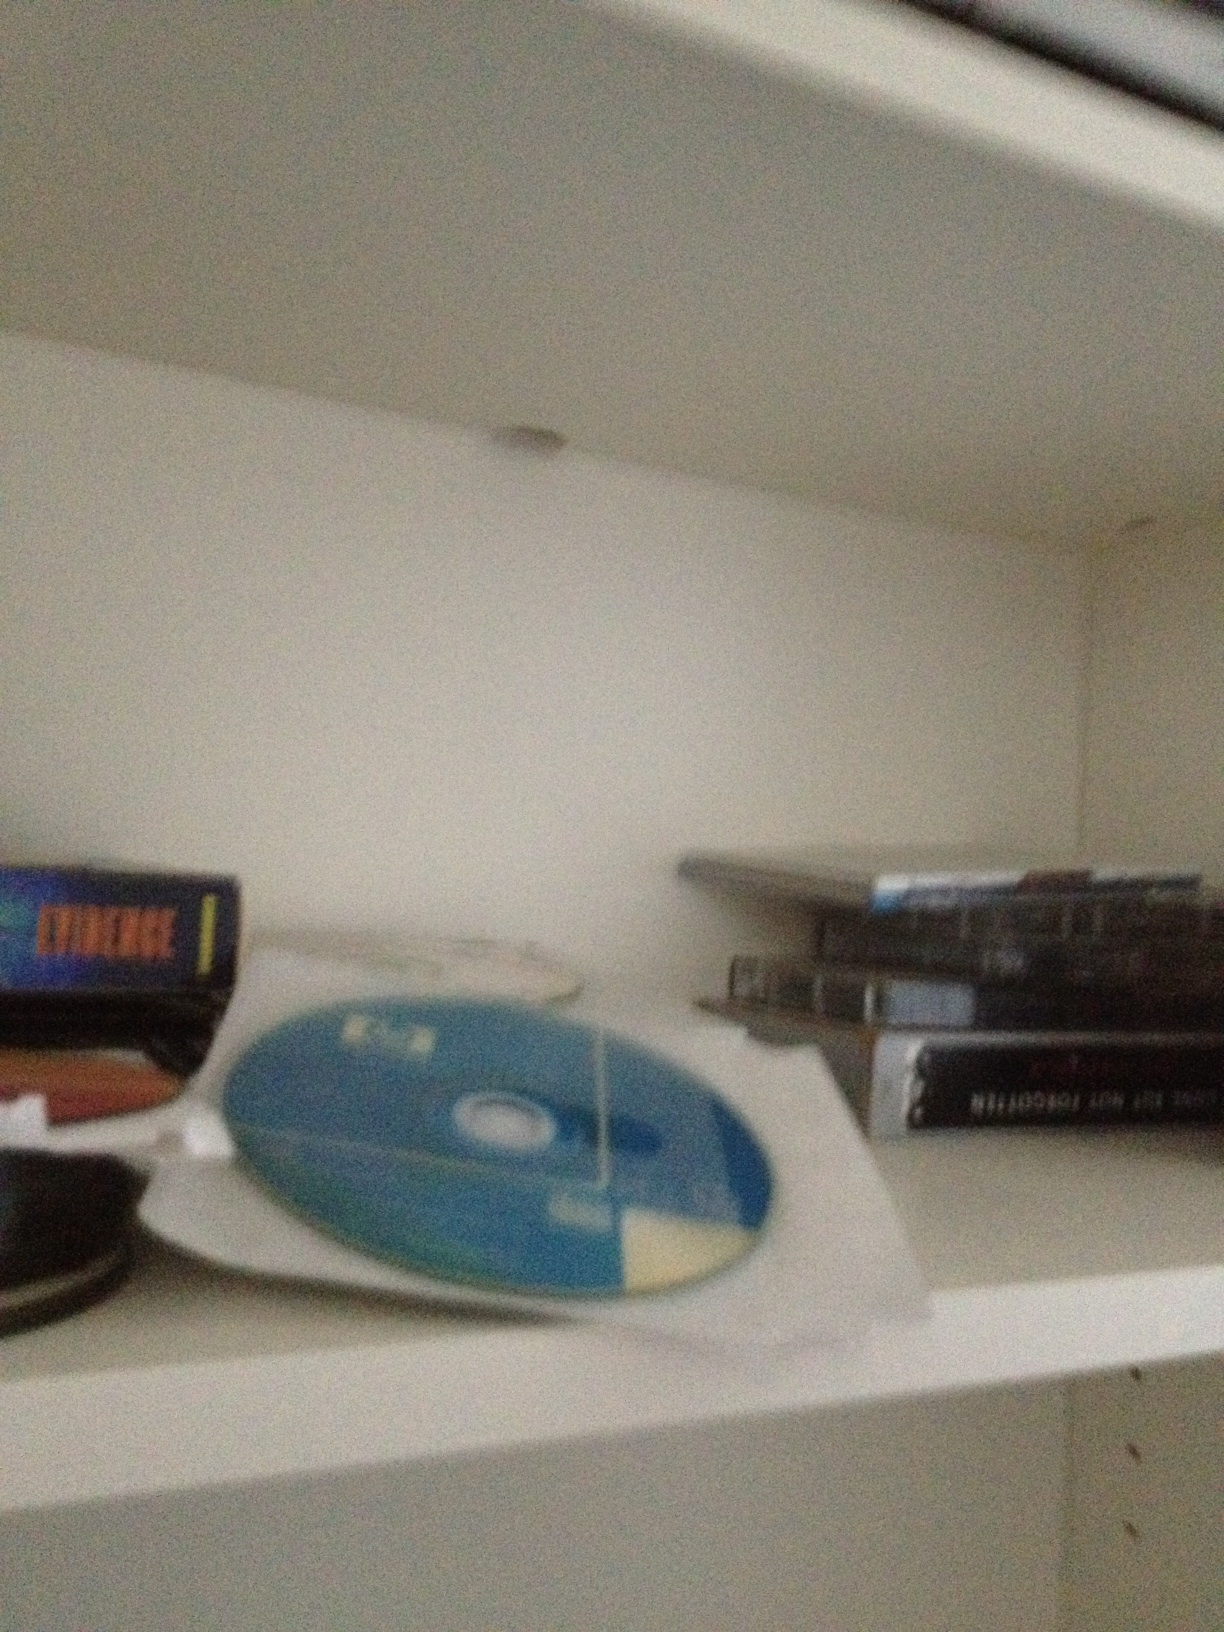Can you imagine a story about how this collection came to be? Once upon a time, in the heart of a bustling city, there was a young music enthusiast named Alex. Alex inherited this diverse collection of CDs and DVDs from their grandfather, who was a passionate collector of music and software. Over the years, Alex added more items to the collection, mixing old classics with new hits. Each disc held a special memory, a concert attended, or a software that marked a milestone in Alex’s life. The shelf became a timeline of evolving tastes and technologies, a testament to a shared love for media that bridged generations. 